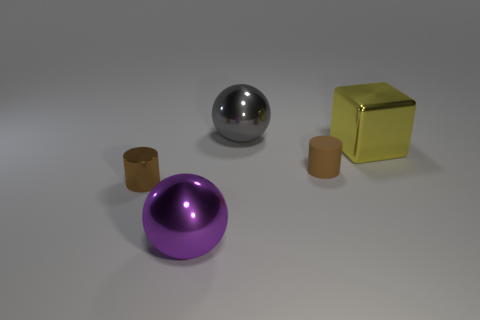Add 1 cubes. How many objects exist? 6 Subtract all balls. How many objects are left? 3 Add 1 shiny objects. How many shiny objects are left? 5 Add 2 big blue things. How many big blue things exist? 2 Subtract 0 gray cubes. How many objects are left? 5 Subtract all small brown cylinders. Subtract all large gray shiny balls. How many objects are left? 2 